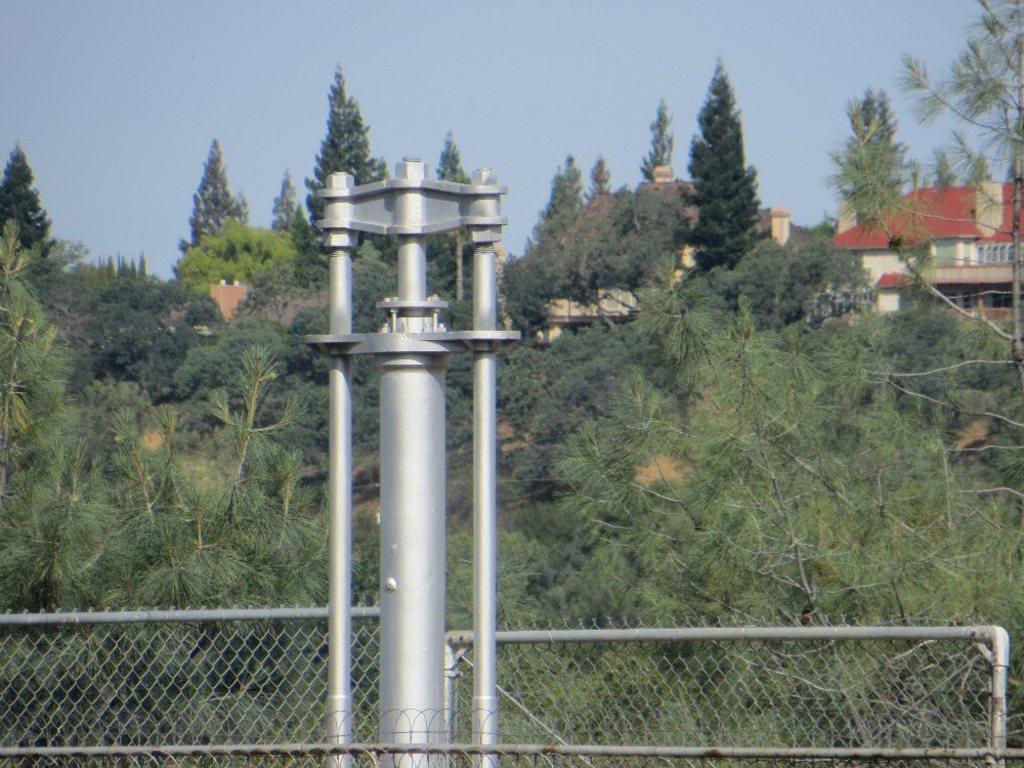Describe this image in one or two sentences. In this image I can see a pole, fencing, number of trees, few buildings and the sky in background. 